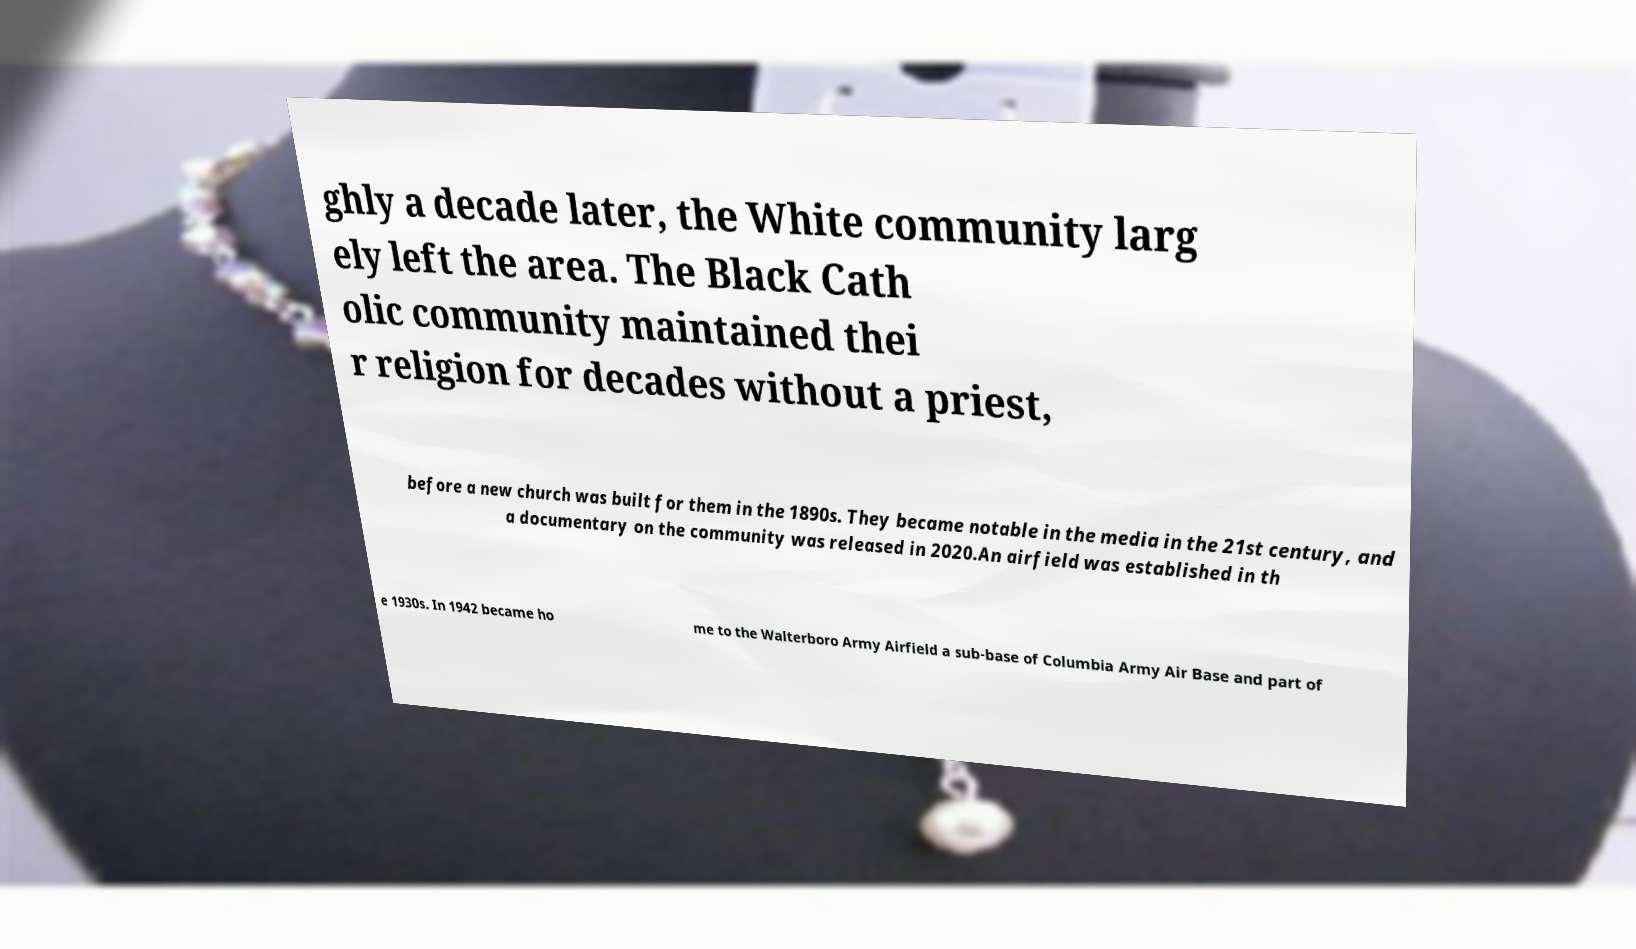I need the written content from this picture converted into text. Can you do that? ghly a decade later, the White community larg ely left the area. The Black Cath olic community maintained thei r religion for decades without a priest, before a new church was built for them in the 1890s. They became notable in the media in the 21st century, and a documentary on the community was released in 2020.An airfield was established in th e 1930s. In 1942 became ho me to the Walterboro Army Airfield a sub-base of Columbia Army Air Base and part of 